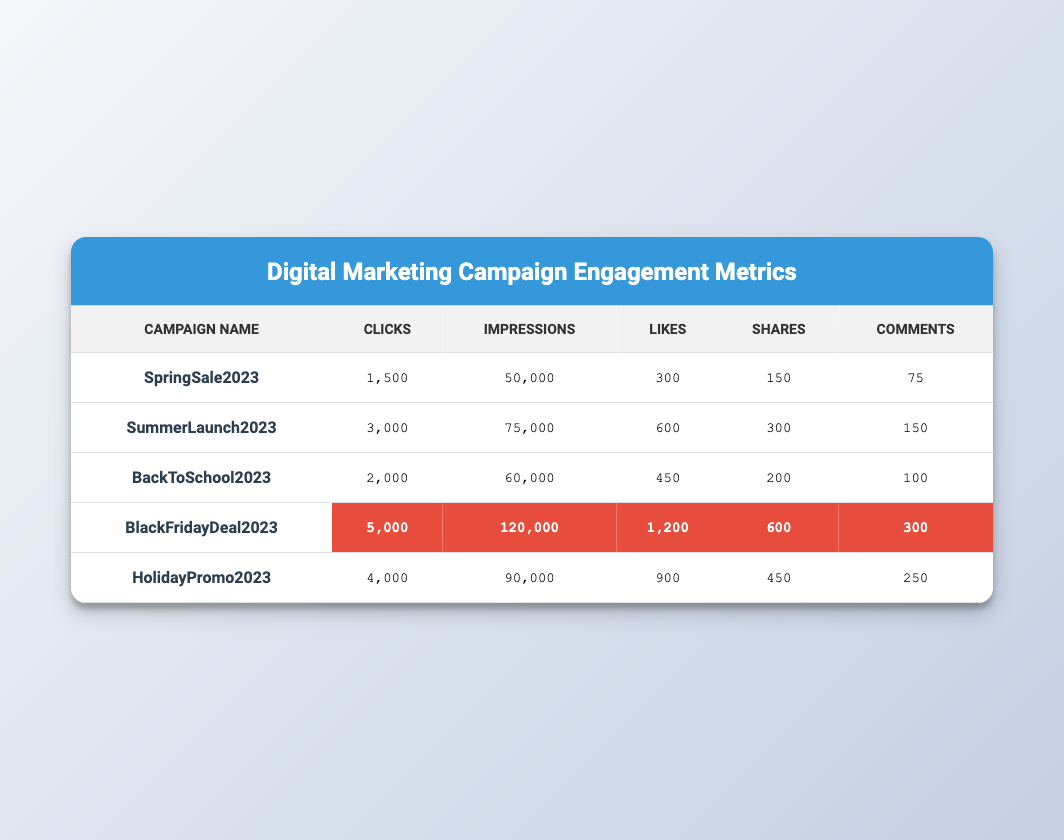What campaign had the highest number of clicks? By looking at the "Clicks" column, we see that the highest value is 5000 for the campaign "BlackFridayDeal2023."
Answer: BlackFridayDeal2023 What is the total number of likes across all campaigns? To find the total likes, add all values in the "Likes" column: 300 + 600 + 450 + 1200 + 900 = 3450.
Answer: 3450 Is the number of shares for the "HolidayPromo2023" higher than for "BackToSchool2023"? The shares for "HolidayPromo2023" are 450, while for "BackToSchool2023" they are 200. Since 450 > 200, the answer is yes.
Answer: Yes What is the average number of impressions for the campaigns listed? To calculate the average, sum the impressions: 50000 + 75000 + 60000 + 120000 + 90000 = 405000, and divide by the number of campaigns (5): 405000 / 5 = 81000.
Answer: 81000 Which campaign had the most comments, and how many comments did it have? Looking at the "Comments" column, the highest value is 300, which corresponds to the "BlackFridayDeal2023" campaign.
Answer: BlackFridayDeal2023, 300 What is the difference in the number of clicks between "SummerLaunch2023" and "SpringSale2023"? The clicks for "SummerLaunch2023" are 3000 and for "SpringSale2023" are 1500. The difference is 3000 - 1500 = 1500.
Answer: 1500 Does the "BlackFridayDeal2023" campaign have the highest engagement metrics in all categories? Comparing all categories, "BlackFridayDeal2023" has the highest values in clicks, impressions, likes, shares, and comments, confirming it's the top engagement campaign.
Answer: Yes What campaign had the least number of likes, and how many were there? The least number of likes is 300 for the "SpringSale2023" campaign.
Answer: SpringSale2023, 300 